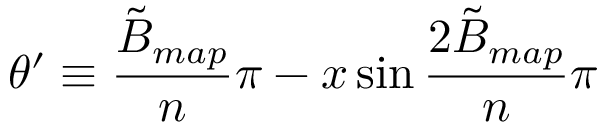<formula> <loc_0><loc_0><loc_500><loc_500>\theta ^ { \prime } \equiv \frac { \tilde { B } _ { m a p } } { n } \pi - x \sin { \frac { 2 \tilde { B } _ { m a p } } { n } \pi }</formula> 